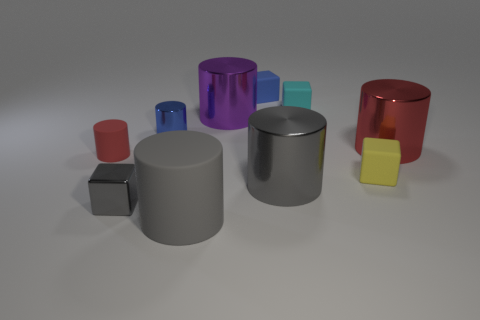Subtract all cyan cubes. How many cubes are left? 3 Subtract all cyan cubes. How many cubes are left? 3 Subtract 4 cylinders. How many cylinders are left? 2 Subtract all cubes. How many objects are left? 6 Subtract all brown blocks. How many red cylinders are left? 2 Add 1 blue rubber cylinders. How many blue rubber cylinders exist? 1 Subtract 0 red balls. How many objects are left? 10 Subtract all brown cylinders. Subtract all purple balls. How many cylinders are left? 6 Subtract all blue rubber cubes. Subtract all tiny blue cubes. How many objects are left? 8 Add 7 large red metallic things. How many large red metallic things are left? 8 